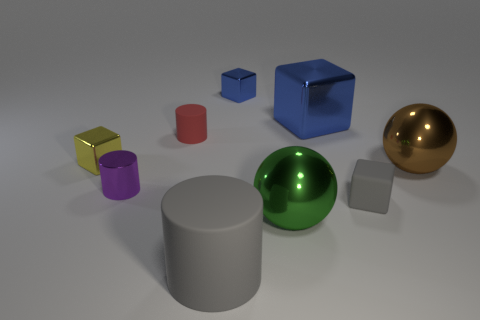How many other blocks have the same color as the large shiny cube?
Your answer should be very brief. 1. The gray rubber object that is the same shape as the yellow shiny object is what size?
Offer a terse response. Small. Are there any red shiny cylinders?
Keep it short and to the point. No. What number of things are small objects in front of the large blue thing or gray blocks?
Give a very brief answer. 4. There is a blue block that is the same size as the brown metallic ball; what is it made of?
Keep it short and to the point. Metal. There is a tiny shiny cube in front of the big metal object that is behind the red rubber thing; what is its color?
Provide a short and direct response. Yellow. What number of cubes are in front of the purple cylinder?
Provide a short and direct response. 1. What is the color of the small rubber cylinder?
Offer a terse response. Red. How many small objects are either yellow shiny objects or metal objects?
Provide a short and direct response. 3. Does the small cube that is behind the small red thing have the same color as the small block that is on the left side of the small purple metallic thing?
Your response must be concise. No. 